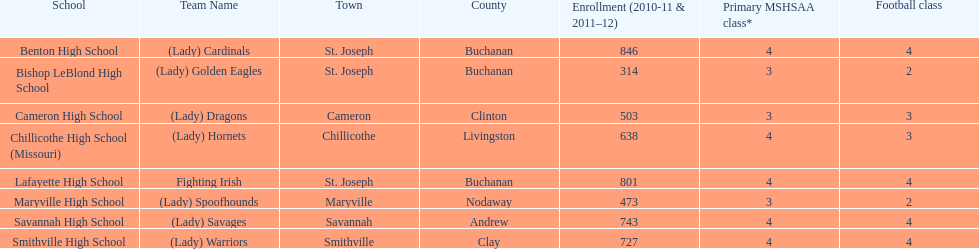How many schools are there in this conference? 8. 